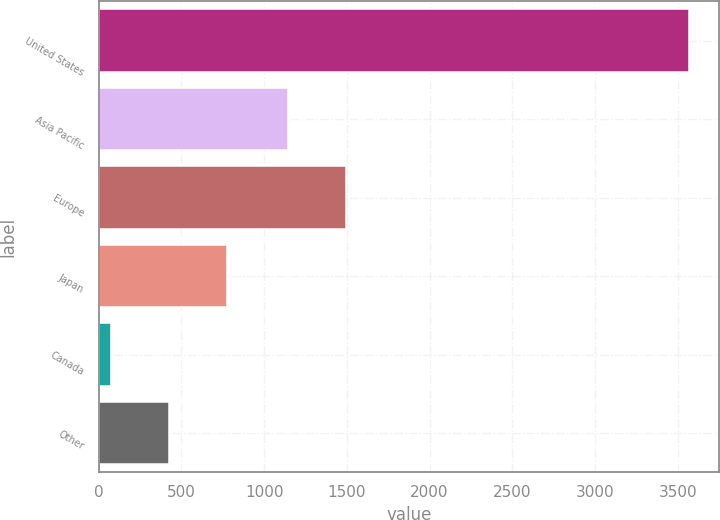Convert chart. <chart><loc_0><loc_0><loc_500><loc_500><bar_chart><fcel>United States<fcel>Asia Pacific<fcel>Europe<fcel>Japan<fcel>Canada<fcel>Other<nl><fcel>3570.8<fcel>1144.8<fcel>1494.15<fcel>776<fcel>77.3<fcel>426.65<nl></chart> 